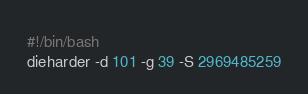Convert code to text. <code><loc_0><loc_0><loc_500><loc_500><_Bash_>#!/bin/bash
dieharder -d 101 -g 39 -S 2969485259
</code> 